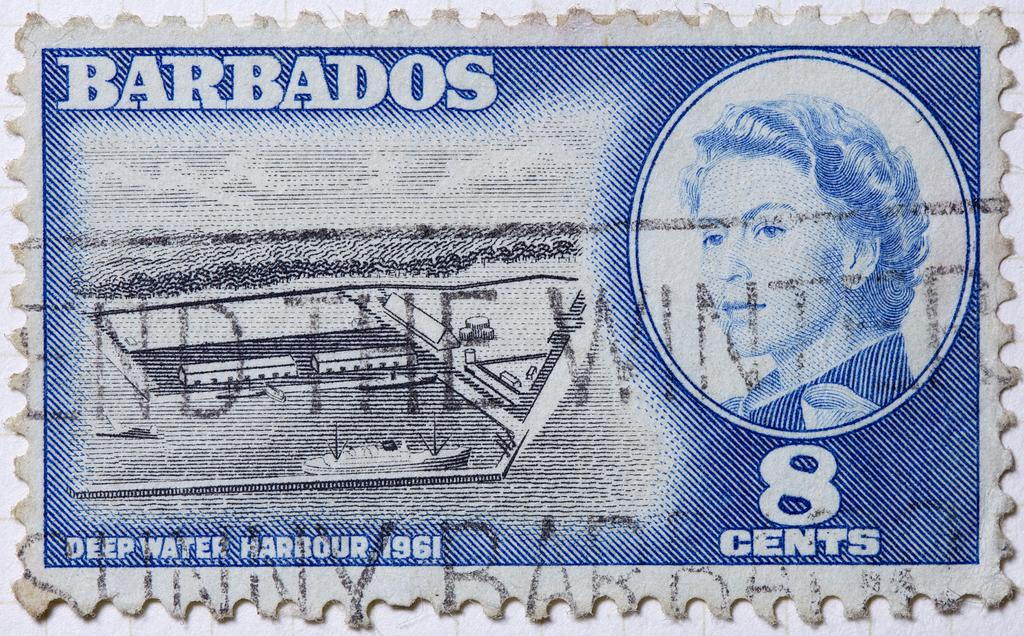What type of item is depicted in the image? The image is of a currency. Can you describe the main feature on the currency? There is a picture of a person on the currency. What else can be seen on the currency besides the person's picture? There is writing around the person's picture on the currency. How many stars are visible on the person's shirt in the image? There are no stars visible on the person's shirt in the image, as the image is of a currency and not a photograph of a person. 